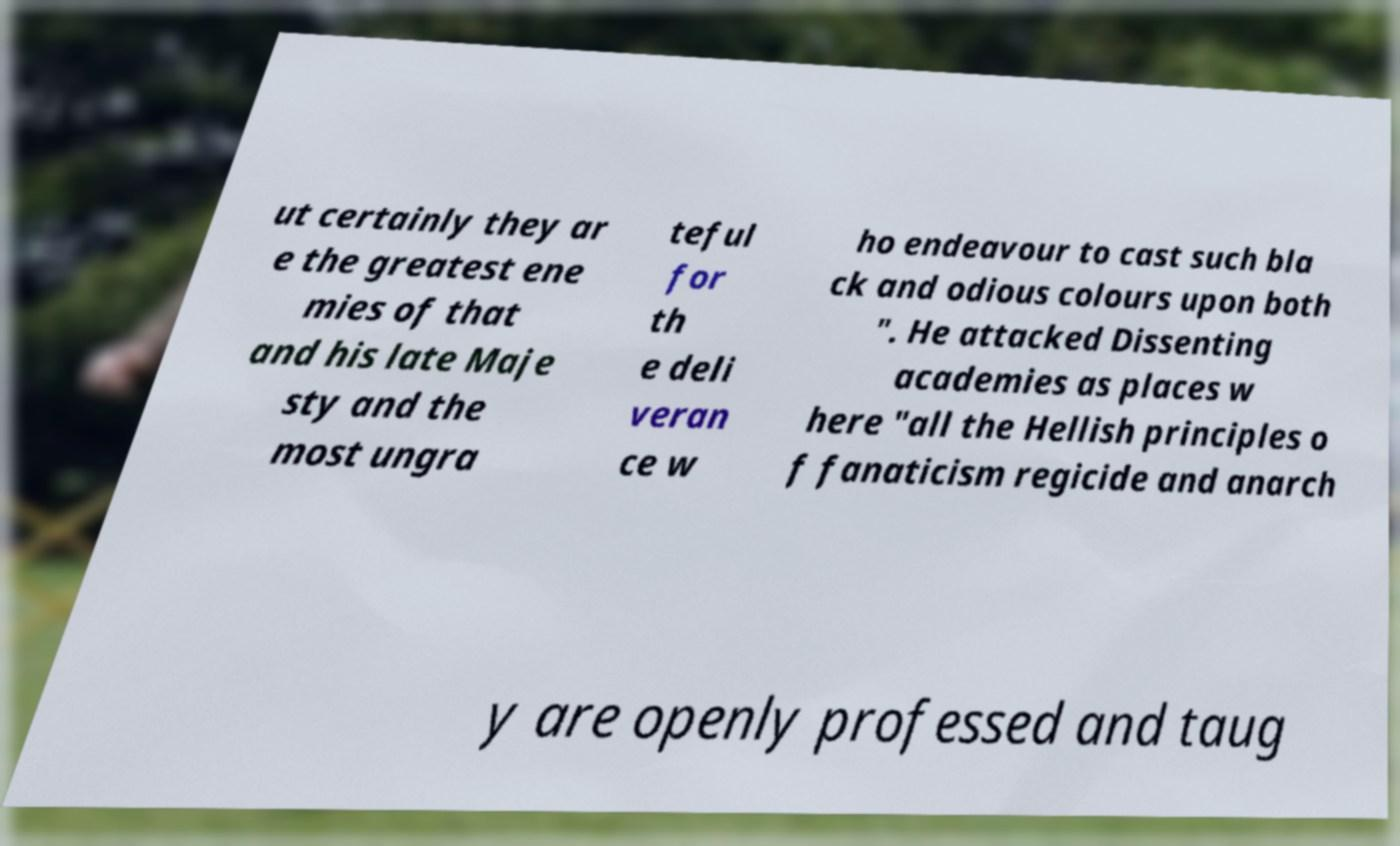What messages or text are displayed in this image? I need them in a readable, typed format. ut certainly they ar e the greatest ene mies of that and his late Maje sty and the most ungra teful for th e deli veran ce w ho endeavour to cast such bla ck and odious colours upon both ". He attacked Dissenting academies as places w here "all the Hellish principles o f fanaticism regicide and anarch y are openly professed and taug 